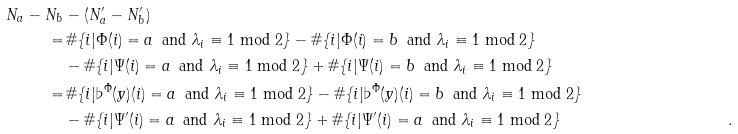Convert formula to latex. <formula><loc_0><loc_0><loc_500><loc_500>N _ { a } - N _ { b } & - ( N ^ { \prime } _ { a } - N ^ { \prime } _ { b } ) & \\ = & \, \# \{ i | \Phi ( i ) = a \ \, \text {and    $\lambda_{i}\equiv 1\bmod{2}$} \} - \# \{ i | \Phi ( i ) = b \ \, \text {and $\lambda_{i}\equiv 1\bmod{2}$} \} & \\ & - \# \{ i | \Psi ( i ) = a \ \, \text {and $\lambda_{i}\equiv    1\bmod{2}$} \} + \# \{ i | \Psi ( i ) = b \ \, \text {and    $\lambda_{i}\equiv 1\bmod{2}$} \} & \\ = & \, \# \{ i | \flat ^ { \Phi } ( y ) ( i ) = a \ \, \text {and    $\lambda_{i}\equiv 1\bmod{2}$} \} - \# \{ i | \flat ^ { \Phi } ( y ) ( i ) = b \ \, \text {and $\lambda_{i}\equiv    1\bmod{2}$} \} & \\ & - \# \{ i | \Psi ^ { \prime } ( i ) = a \ \, \text {and    $\lambda_{i}\equiv 1 \bmod{2}$} \} + \# \{ i | \Psi ^ { \prime } ( i ) = a \ \, \text {and $\lambda_{i}\equiv 1\bmod{2}$} \} & .</formula> 